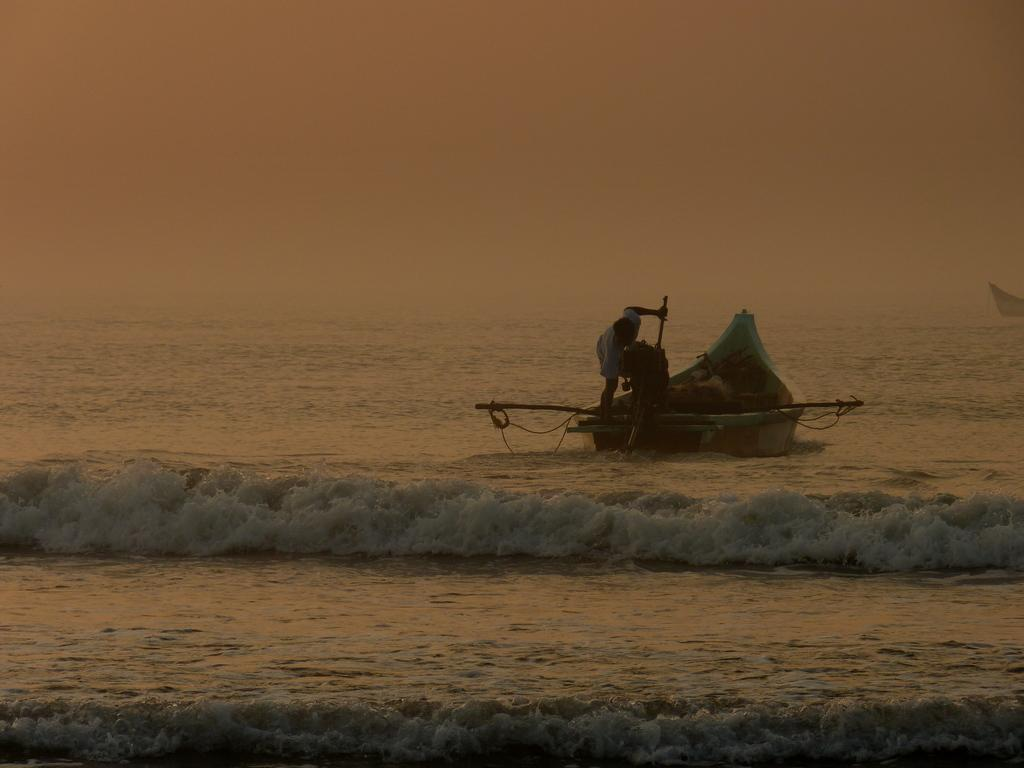What type of landscape is visible in the image? There is a body of water visible in the image. What is on the water in the image? There is a boat in the image. Who is on the boat? A person is on the boat. What is the person on the boat doing? The person is holding things in their hands. Can you describe the other person in the image? There is another person in the background of the image. What type of brass instrument is the person on the boat playing? There is no brass instrument present in the image. Can you describe the cheese that the person on the boat is holding? There is no cheese visible in the image. 